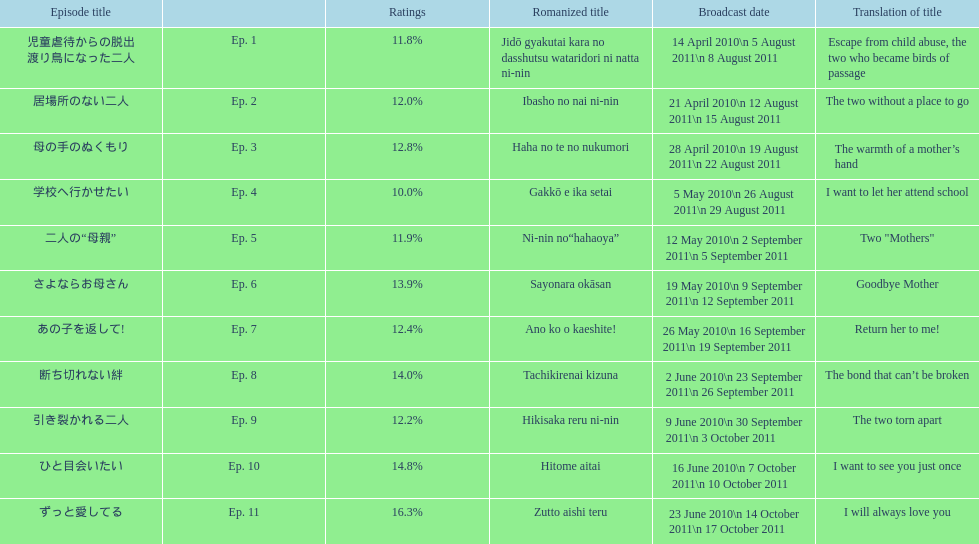What is the name of epsiode 8? 断ち切れない絆. What were this episodes ratings? 14.0%. 